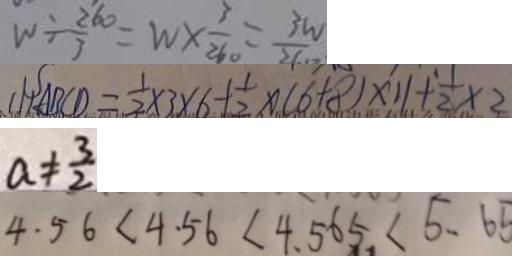Convert formula to latex. <formula><loc_0><loc_0><loc_500><loc_500>W \div \frac { 2 6 0 } { 3 } = w \times \frac { 3 } { 2 6 0 } = \frac { 3 w } { 2 6 0 } 
 ( 1 ) A B C D = \frac { 1 } { 2 } \times 3 \times 6 + \frac { 1 } { 2 } \times ( 6 + 8 ) \times 1 1 + \frac { 1 } { 2 } \times 2 
 a \neq \frac { 3 } { 2 } 
 4 . 5 6 < 4 . 5 6 < 4 . 5 6 5 < 5 . 6 5</formula> 